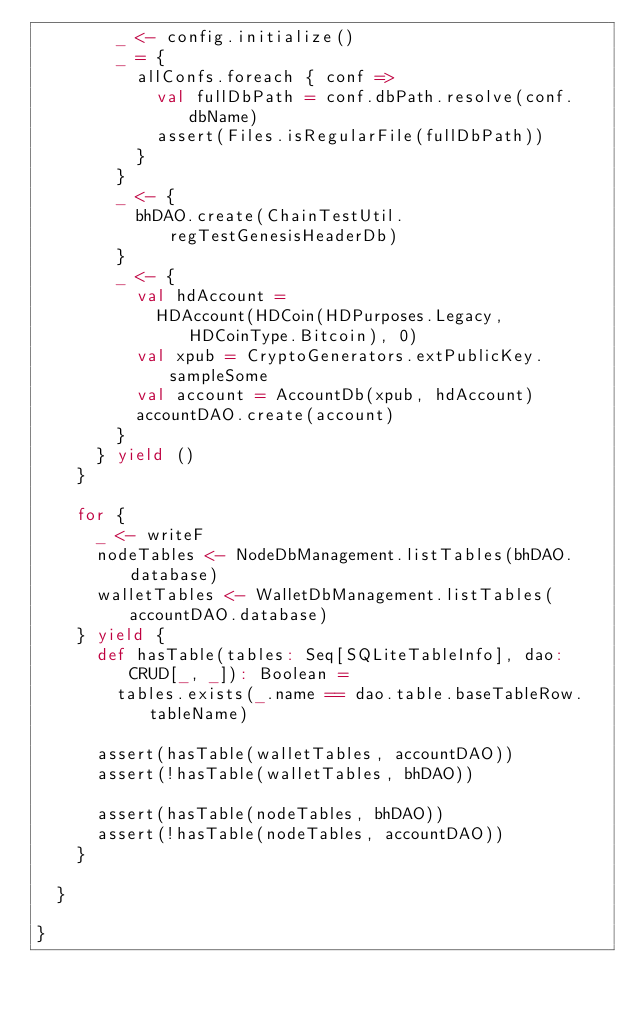Convert code to text. <code><loc_0><loc_0><loc_500><loc_500><_Scala_>        _ <- config.initialize()
        _ = {
          allConfs.foreach { conf =>
            val fullDbPath = conf.dbPath.resolve(conf.dbName)
            assert(Files.isRegularFile(fullDbPath))
          }
        }
        _ <- {
          bhDAO.create(ChainTestUtil.regTestGenesisHeaderDb)
        }
        _ <- {
          val hdAccount =
            HDAccount(HDCoin(HDPurposes.Legacy, HDCoinType.Bitcoin), 0)
          val xpub = CryptoGenerators.extPublicKey.sampleSome
          val account = AccountDb(xpub, hdAccount)
          accountDAO.create(account)
        }
      } yield ()
    }

    for {
      _ <- writeF
      nodeTables <- NodeDbManagement.listTables(bhDAO.database)
      walletTables <- WalletDbManagement.listTables(accountDAO.database)
    } yield {
      def hasTable(tables: Seq[SQLiteTableInfo], dao: CRUD[_, _]): Boolean =
        tables.exists(_.name == dao.table.baseTableRow.tableName)

      assert(hasTable(walletTables, accountDAO))
      assert(!hasTable(walletTables, bhDAO))

      assert(hasTable(nodeTables, bhDAO))
      assert(!hasTable(nodeTables, accountDAO))
    }

  }

}
</code> 